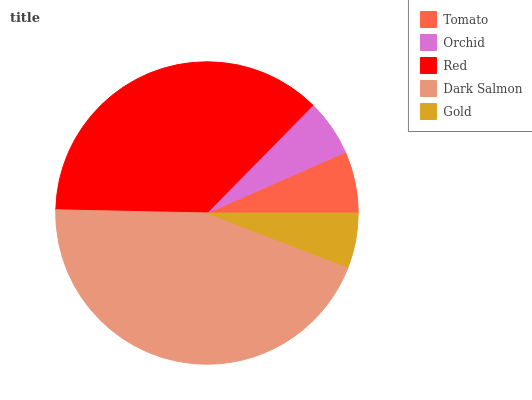Is Gold the minimum?
Answer yes or no. Yes. Is Dark Salmon the maximum?
Answer yes or no. Yes. Is Orchid the minimum?
Answer yes or no. No. Is Orchid the maximum?
Answer yes or no. No. Is Tomato greater than Orchid?
Answer yes or no. Yes. Is Orchid less than Tomato?
Answer yes or no. Yes. Is Orchid greater than Tomato?
Answer yes or no. No. Is Tomato less than Orchid?
Answer yes or no. No. Is Tomato the high median?
Answer yes or no. Yes. Is Tomato the low median?
Answer yes or no. Yes. Is Orchid the high median?
Answer yes or no. No. Is Orchid the low median?
Answer yes or no. No. 